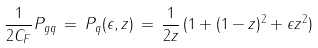<formula> <loc_0><loc_0><loc_500><loc_500>\frac { 1 } { 2 C _ { F } } P _ { g q } \, = \, P _ { q } ( \epsilon , z ) \, = \, \frac { 1 } { 2 z } \, ( 1 + ( 1 - z ) ^ { 2 } + \epsilon z ^ { 2 } )</formula> 